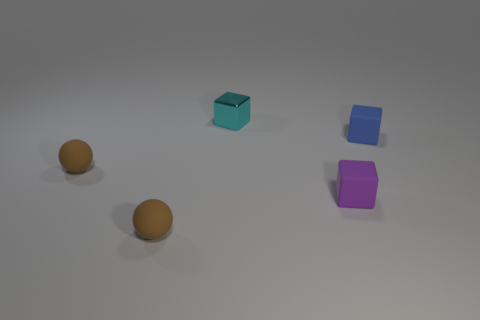Subtract all tiny cyan blocks. How many blocks are left? 2 Add 2 gray cylinders. How many objects exist? 7 Subtract all purple blocks. How many blocks are left? 2 Subtract 0 cyan balls. How many objects are left? 5 Subtract all spheres. How many objects are left? 3 Subtract 2 balls. How many balls are left? 0 Subtract all red cubes. Subtract all green spheres. How many cubes are left? 3 Subtract all blue balls. How many blue blocks are left? 1 Subtract all tiny purple rubber objects. Subtract all tiny brown things. How many objects are left? 2 Add 3 tiny balls. How many tiny balls are left? 5 